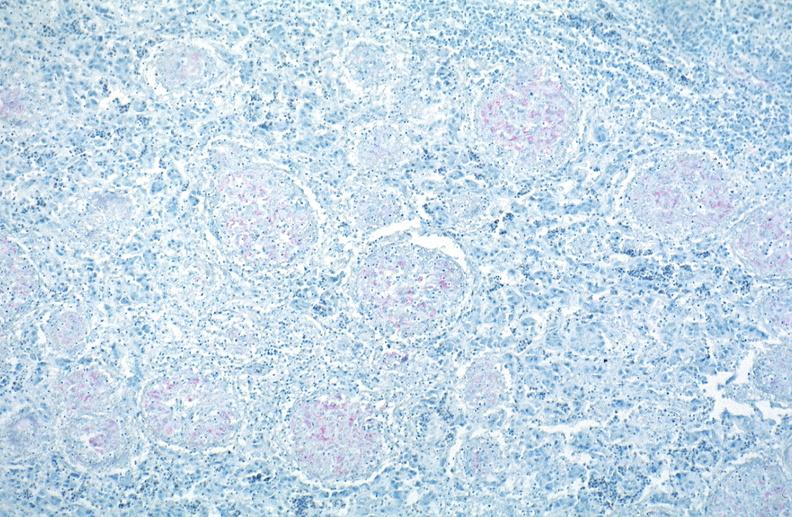does this image show lung, mycobacterium tuberculosis, acid fast?
Answer the question using a single word or phrase. Yes 